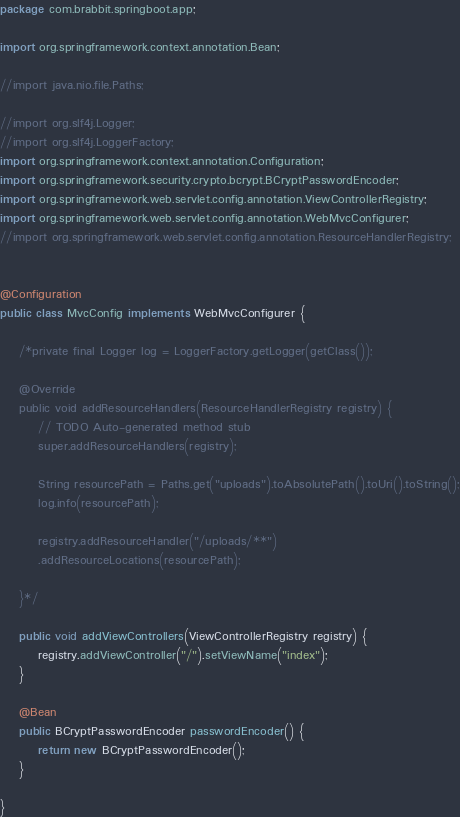<code> <loc_0><loc_0><loc_500><loc_500><_Java_>package com.brabbit.springboot.app;

import org.springframework.context.annotation.Bean;

//import java.nio.file.Paths;

//import org.slf4j.Logger;
//import org.slf4j.LoggerFactory;
import org.springframework.context.annotation.Configuration;
import org.springframework.security.crypto.bcrypt.BCryptPasswordEncoder;
import org.springframework.web.servlet.config.annotation.ViewControllerRegistry;
import org.springframework.web.servlet.config.annotation.WebMvcConfigurer;
//import org.springframework.web.servlet.config.annotation.ResourceHandlerRegistry;


@Configuration
public class MvcConfig implements WebMvcConfigurer {

	/*private final Logger log = LoggerFactory.getLogger(getClass());
	
	@Override
	public void addResourceHandlers(ResourceHandlerRegistry registry) {
		// TODO Auto-generated method stub
		super.addResourceHandlers(registry);
		
		String resourcePath = Paths.get("uploads").toAbsolutePath().toUri().toString();
		log.info(resourcePath);
		
		registry.addResourceHandler("/uploads/**")
		.addResourceLocations(resourcePath);
		
	}*/
	
	public void addViewControllers(ViewControllerRegistry registry) {
		registry.addViewController("/").setViewName("index");
	}

	@Bean
	public BCryptPasswordEncoder passwordEncoder() {
		return new BCryptPasswordEncoder();
	}
	
}
</code> 